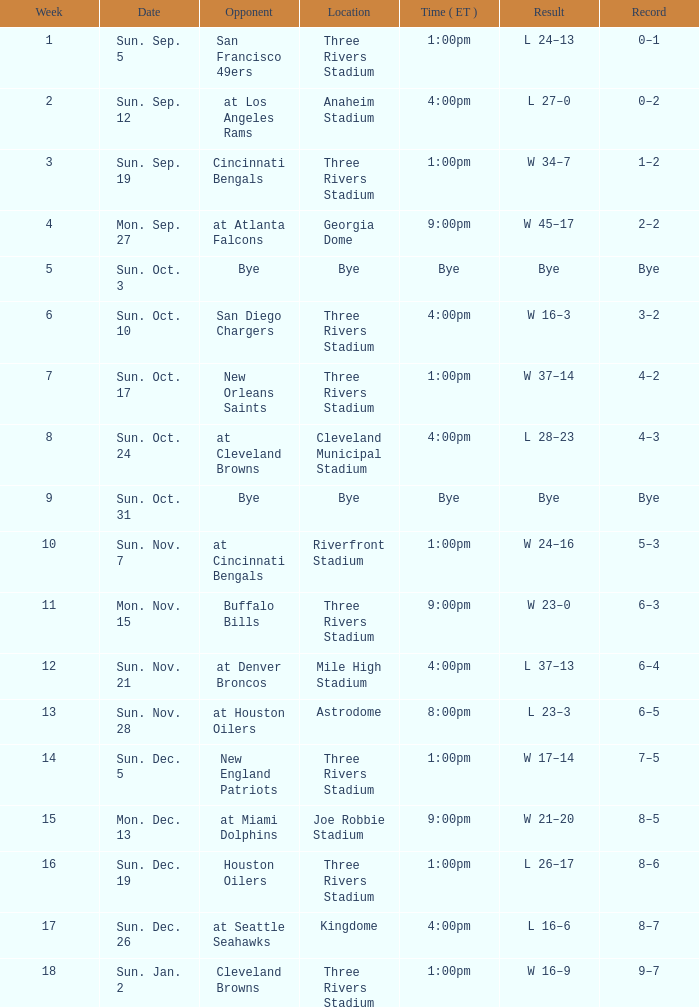What is the result of the game at three rivers stadium with a Record of 6–3? W 23–0. Could you parse the entire table? {'header': ['Week', 'Date', 'Opponent', 'Location', 'Time ( ET )', 'Result', 'Record'], 'rows': [['1', 'Sun. Sep. 5', 'San Francisco 49ers', 'Three Rivers Stadium', '1:00pm', 'L 24–13', '0–1'], ['2', 'Sun. Sep. 12', 'at Los Angeles Rams', 'Anaheim Stadium', '4:00pm', 'L 27–0', '0–2'], ['3', 'Sun. Sep. 19', 'Cincinnati Bengals', 'Three Rivers Stadium', '1:00pm', 'W 34–7', '1–2'], ['4', 'Mon. Sep. 27', 'at Atlanta Falcons', 'Georgia Dome', '9:00pm', 'W 45–17', '2–2'], ['5', 'Sun. Oct. 3', 'Bye', 'Bye', 'Bye', 'Bye', 'Bye'], ['6', 'Sun. Oct. 10', 'San Diego Chargers', 'Three Rivers Stadium', '4:00pm', 'W 16–3', '3–2'], ['7', 'Sun. Oct. 17', 'New Orleans Saints', 'Three Rivers Stadium', '1:00pm', 'W 37–14', '4–2'], ['8', 'Sun. Oct. 24', 'at Cleveland Browns', 'Cleveland Municipal Stadium', '4:00pm', 'L 28–23', '4–3'], ['9', 'Sun. Oct. 31', 'Bye', 'Bye', 'Bye', 'Bye', 'Bye'], ['10', 'Sun. Nov. 7', 'at Cincinnati Bengals', 'Riverfront Stadium', '1:00pm', 'W 24–16', '5–3'], ['11', 'Mon. Nov. 15', 'Buffalo Bills', 'Three Rivers Stadium', '9:00pm', 'W 23–0', '6–3'], ['12', 'Sun. Nov. 21', 'at Denver Broncos', 'Mile High Stadium', '4:00pm', 'L 37–13', '6–4'], ['13', 'Sun. Nov. 28', 'at Houston Oilers', 'Astrodome', '8:00pm', 'L 23–3', '6–5'], ['14', 'Sun. Dec. 5', 'New England Patriots', 'Three Rivers Stadium', '1:00pm', 'W 17–14', '7–5'], ['15', 'Mon. Dec. 13', 'at Miami Dolphins', 'Joe Robbie Stadium', '9:00pm', 'W 21–20', '8–5'], ['16', 'Sun. Dec. 19', 'Houston Oilers', 'Three Rivers Stadium', '1:00pm', 'L 26–17', '8–6'], ['17', 'Sun. Dec. 26', 'at Seattle Seahawks', 'Kingdome', '4:00pm', 'L 16–6', '8–7'], ['18', 'Sun. Jan. 2', 'Cleveland Browns', 'Three Rivers Stadium', '1:00pm', 'W 16–9', '9–7']]} 